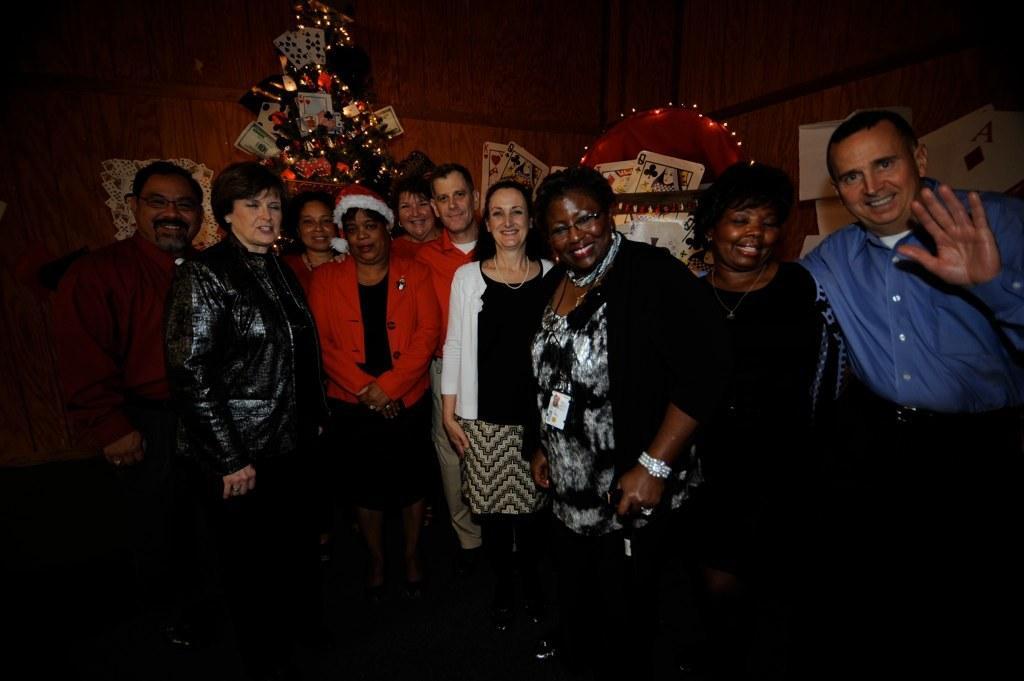Could you give a brief overview of what you see in this image? In this image I see a group of people standing and all of them are smiling. In the background I see a Christmas tree, which is decorated by lights and playing cards and I see the wall. 